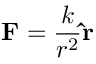Convert formula to latex. <formula><loc_0><loc_0><loc_500><loc_500>F = { \frac { k } { r ^ { 2 } } } \hat { r }</formula> 